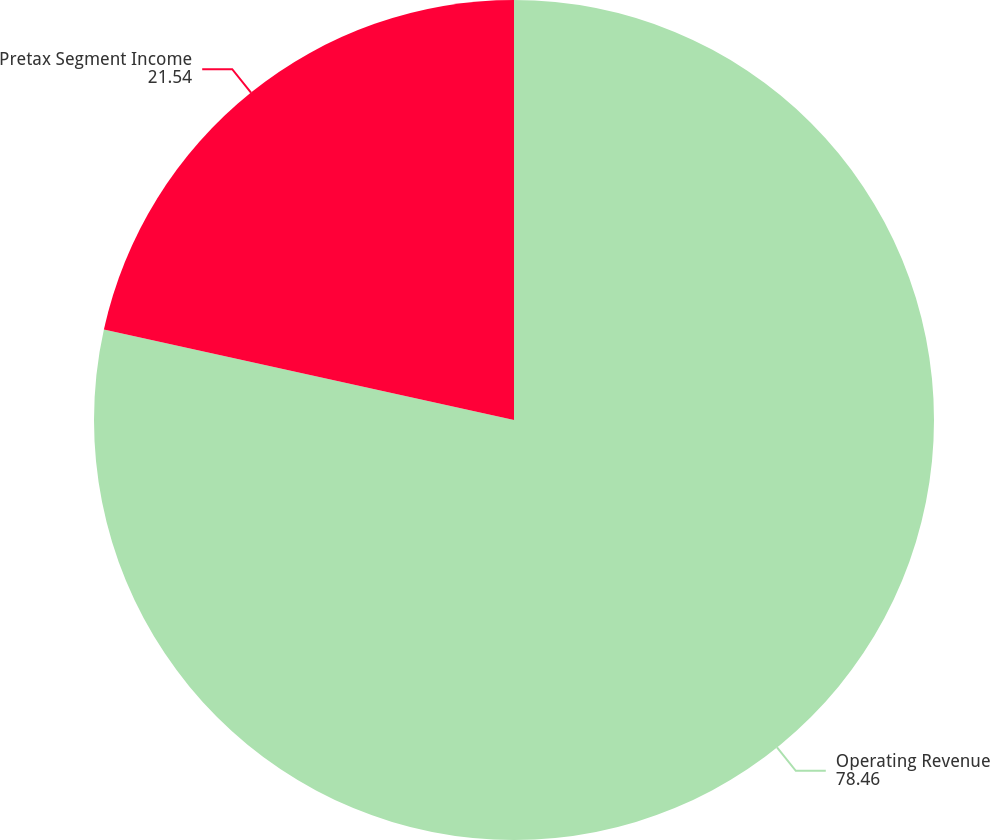Convert chart to OTSL. <chart><loc_0><loc_0><loc_500><loc_500><pie_chart><fcel>Operating Revenue<fcel>Pretax Segment Income<nl><fcel>78.46%<fcel>21.54%<nl></chart> 